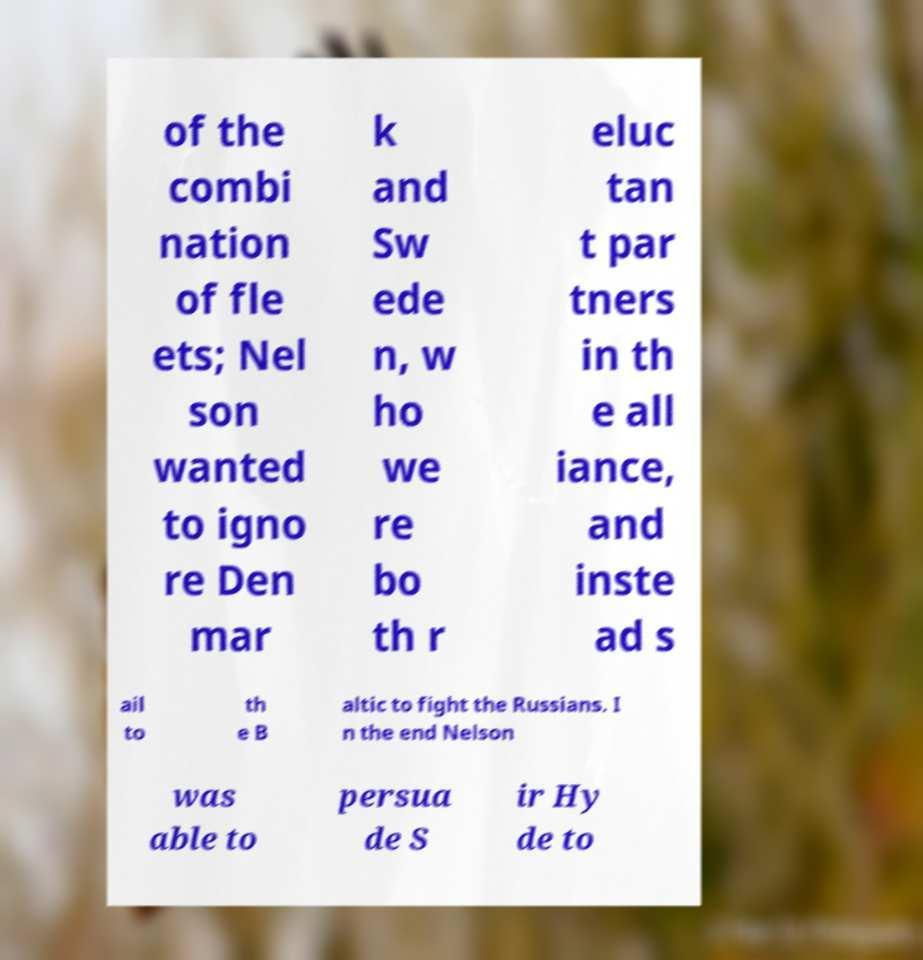Could you assist in decoding the text presented in this image and type it out clearly? of the combi nation of fle ets; Nel son wanted to igno re Den mar k and Sw ede n, w ho we re bo th r eluc tan t par tners in th e all iance, and inste ad s ail to th e B altic to fight the Russians. I n the end Nelson was able to persua de S ir Hy de to 